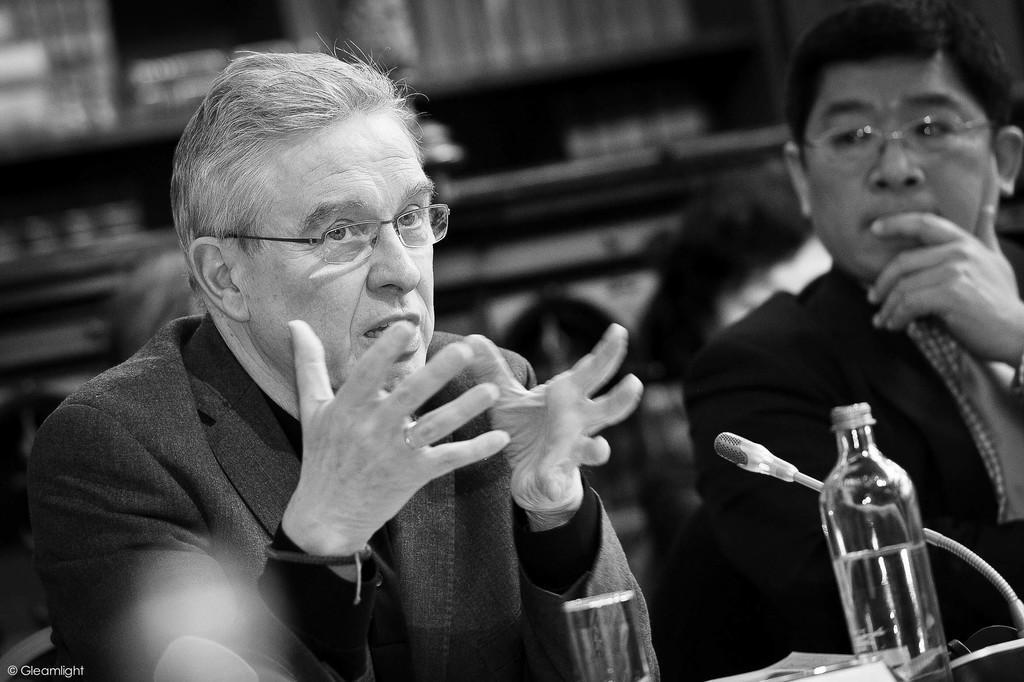Please provide a concise description of this image. In this picture there is a person who is sitting at the right side of the image he is explaining something, and there is another person who is sitting at the right side of the image, there is a mic in front of him and there is a glass, and bottle on the table the background of the image is black and white in color. 